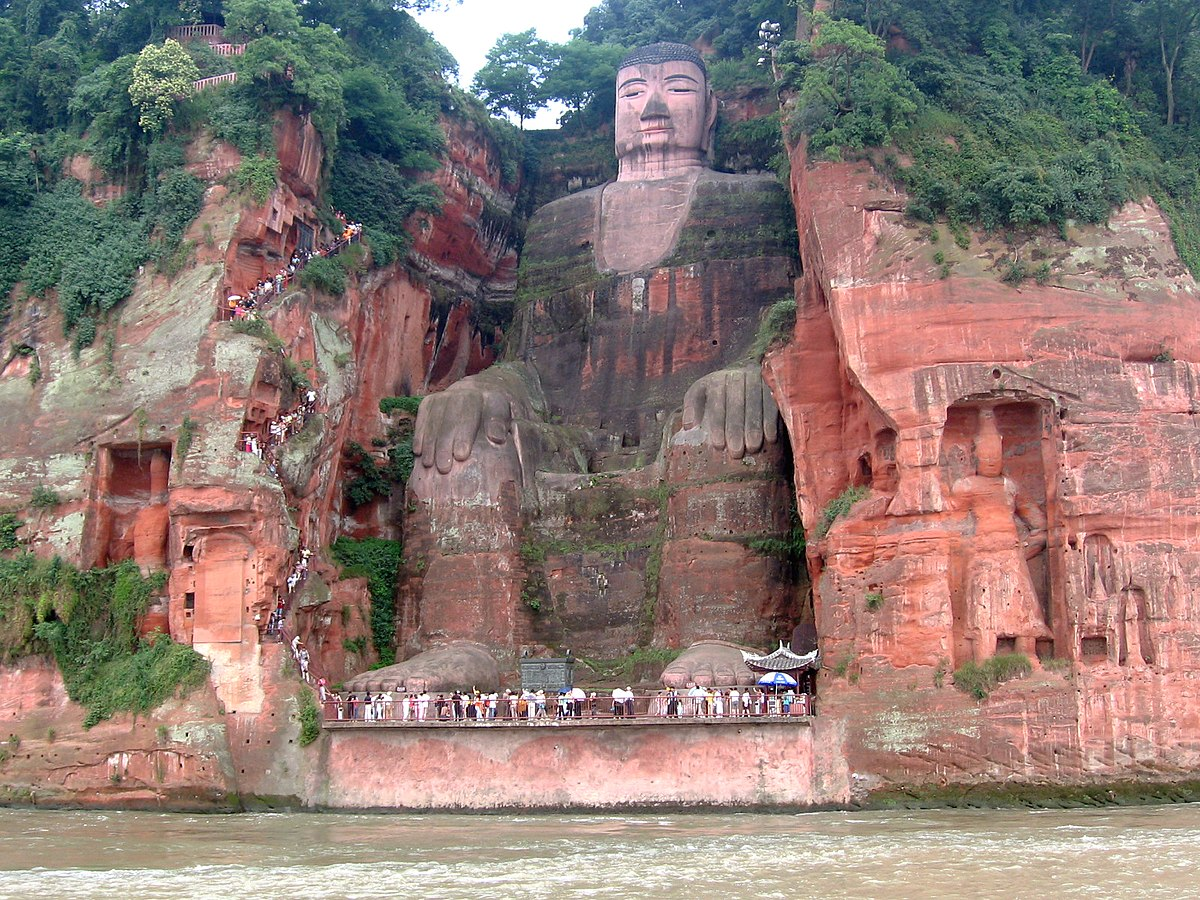What do you think is going on in this snapshot? The image captures the grandeur of the Leshan Giant Buddha, a monumental stone statue located in Leshan, China. The Buddha, carved into the side of a cliff, sits in a serene pose, exuding an aura of tranquility. The statue, towering at a height of 71 meters, is surrounded by lush green trees, adding a touch of nature's vibrancy to the scene.

A river flows gently at the base of the cliff, its waters reflecting the majestic Buddha and the verdant foliage. The perspective of the image gives a sense of the immense scale of the statue, with people appearing minuscule as they walk along a path at the base of the Buddha and on a viewing platform on the cliff face.

The image is a testament to the remarkable craftsmanship of the sculptors and the enduring allure of this world-renowned landmark. The Leshan Giant Buddha, with its intricate details and impressive size, continues to be a symbol of spiritual reverence and artistic excellence. 